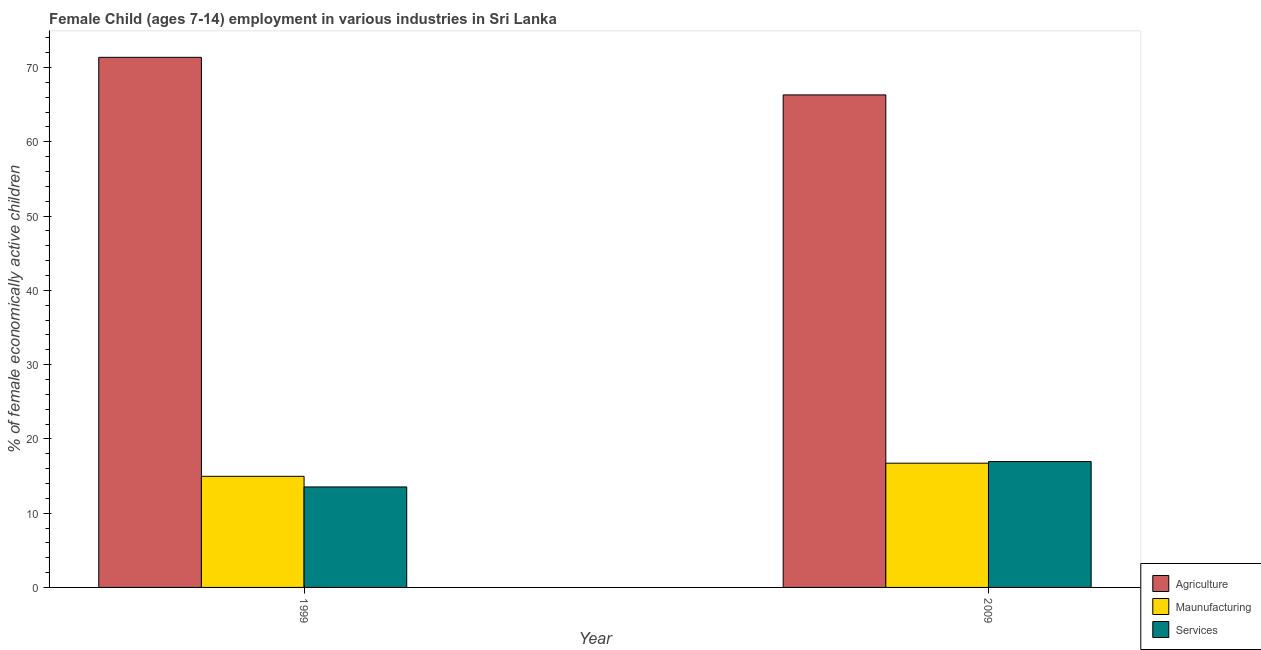How many groups of bars are there?
Provide a succinct answer. 2. Are the number of bars per tick equal to the number of legend labels?
Give a very brief answer. Yes. How many bars are there on the 2nd tick from the right?
Ensure brevity in your answer.  3. What is the label of the 1st group of bars from the left?
Ensure brevity in your answer.  1999. What is the percentage of economically active children in manufacturing in 1999?
Provide a succinct answer. 14.96. Across all years, what is the maximum percentage of economically active children in agriculture?
Make the answer very short. 71.38. Across all years, what is the minimum percentage of economically active children in agriculture?
Provide a succinct answer. 66.32. In which year was the percentage of economically active children in agriculture maximum?
Your response must be concise. 1999. In which year was the percentage of economically active children in agriculture minimum?
Offer a terse response. 2009. What is the total percentage of economically active children in agriculture in the graph?
Provide a short and direct response. 137.7. What is the difference between the percentage of economically active children in agriculture in 1999 and that in 2009?
Your answer should be compact. 5.06. What is the difference between the percentage of economically active children in manufacturing in 1999 and the percentage of economically active children in services in 2009?
Make the answer very short. -1.77. What is the average percentage of economically active children in manufacturing per year?
Ensure brevity in your answer.  15.85. In the year 2009, what is the difference between the percentage of economically active children in services and percentage of economically active children in manufacturing?
Ensure brevity in your answer.  0. In how many years, is the percentage of economically active children in manufacturing greater than 50 %?
Offer a terse response. 0. What is the ratio of the percentage of economically active children in manufacturing in 1999 to that in 2009?
Offer a terse response. 0.89. What does the 1st bar from the left in 1999 represents?
Make the answer very short. Agriculture. What does the 3rd bar from the right in 1999 represents?
Make the answer very short. Agriculture. Is it the case that in every year, the sum of the percentage of economically active children in agriculture and percentage of economically active children in manufacturing is greater than the percentage of economically active children in services?
Provide a succinct answer. Yes. How many bars are there?
Your answer should be very brief. 6. How many years are there in the graph?
Ensure brevity in your answer.  2. What is the difference between two consecutive major ticks on the Y-axis?
Keep it short and to the point. 10. Does the graph contain grids?
Make the answer very short. No. What is the title of the graph?
Your answer should be very brief. Female Child (ages 7-14) employment in various industries in Sri Lanka. What is the label or title of the Y-axis?
Your answer should be very brief. % of female economically active children. What is the % of female economically active children of Agriculture in 1999?
Provide a succinct answer. 71.38. What is the % of female economically active children of Maunufacturing in 1999?
Your response must be concise. 14.96. What is the % of female economically active children of Services in 1999?
Your answer should be very brief. 13.53. What is the % of female economically active children of Agriculture in 2009?
Offer a very short reply. 66.32. What is the % of female economically active children of Maunufacturing in 2009?
Offer a very short reply. 16.73. What is the % of female economically active children in Services in 2009?
Provide a succinct answer. 16.95. Across all years, what is the maximum % of female economically active children in Agriculture?
Give a very brief answer. 71.38. Across all years, what is the maximum % of female economically active children in Maunufacturing?
Your answer should be very brief. 16.73. Across all years, what is the maximum % of female economically active children in Services?
Give a very brief answer. 16.95. Across all years, what is the minimum % of female economically active children of Agriculture?
Your answer should be very brief. 66.32. Across all years, what is the minimum % of female economically active children in Maunufacturing?
Your answer should be very brief. 14.96. Across all years, what is the minimum % of female economically active children in Services?
Keep it short and to the point. 13.53. What is the total % of female economically active children in Agriculture in the graph?
Your answer should be compact. 137.7. What is the total % of female economically active children of Maunufacturing in the graph?
Offer a terse response. 31.69. What is the total % of female economically active children of Services in the graph?
Your response must be concise. 30.48. What is the difference between the % of female economically active children in Agriculture in 1999 and that in 2009?
Your response must be concise. 5.06. What is the difference between the % of female economically active children of Maunufacturing in 1999 and that in 2009?
Offer a terse response. -1.77. What is the difference between the % of female economically active children in Services in 1999 and that in 2009?
Keep it short and to the point. -3.42. What is the difference between the % of female economically active children in Agriculture in 1999 and the % of female economically active children in Maunufacturing in 2009?
Keep it short and to the point. 54.65. What is the difference between the % of female economically active children in Agriculture in 1999 and the % of female economically active children in Services in 2009?
Provide a short and direct response. 54.43. What is the difference between the % of female economically active children in Maunufacturing in 1999 and the % of female economically active children in Services in 2009?
Provide a short and direct response. -1.99. What is the average % of female economically active children in Agriculture per year?
Your response must be concise. 68.85. What is the average % of female economically active children of Maunufacturing per year?
Give a very brief answer. 15.85. What is the average % of female economically active children in Services per year?
Provide a short and direct response. 15.24. In the year 1999, what is the difference between the % of female economically active children of Agriculture and % of female economically active children of Maunufacturing?
Give a very brief answer. 56.42. In the year 1999, what is the difference between the % of female economically active children in Agriculture and % of female economically active children in Services?
Your answer should be compact. 57.85. In the year 1999, what is the difference between the % of female economically active children of Maunufacturing and % of female economically active children of Services?
Keep it short and to the point. 1.43. In the year 2009, what is the difference between the % of female economically active children of Agriculture and % of female economically active children of Maunufacturing?
Your answer should be very brief. 49.59. In the year 2009, what is the difference between the % of female economically active children in Agriculture and % of female economically active children in Services?
Keep it short and to the point. 49.37. In the year 2009, what is the difference between the % of female economically active children in Maunufacturing and % of female economically active children in Services?
Make the answer very short. -0.22. What is the ratio of the % of female economically active children of Agriculture in 1999 to that in 2009?
Offer a very short reply. 1.08. What is the ratio of the % of female economically active children of Maunufacturing in 1999 to that in 2009?
Keep it short and to the point. 0.89. What is the ratio of the % of female economically active children in Services in 1999 to that in 2009?
Keep it short and to the point. 0.8. What is the difference between the highest and the second highest % of female economically active children of Agriculture?
Your answer should be very brief. 5.06. What is the difference between the highest and the second highest % of female economically active children in Maunufacturing?
Give a very brief answer. 1.77. What is the difference between the highest and the second highest % of female economically active children of Services?
Offer a terse response. 3.42. What is the difference between the highest and the lowest % of female economically active children in Agriculture?
Your answer should be very brief. 5.06. What is the difference between the highest and the lowest % of female economically active children in Maunufacturing?
Your answer should be very brief. 1.77. What is the difference between the highest and the lowest % of female economically active children of Services?
Give a very brief answer. 3.42. 